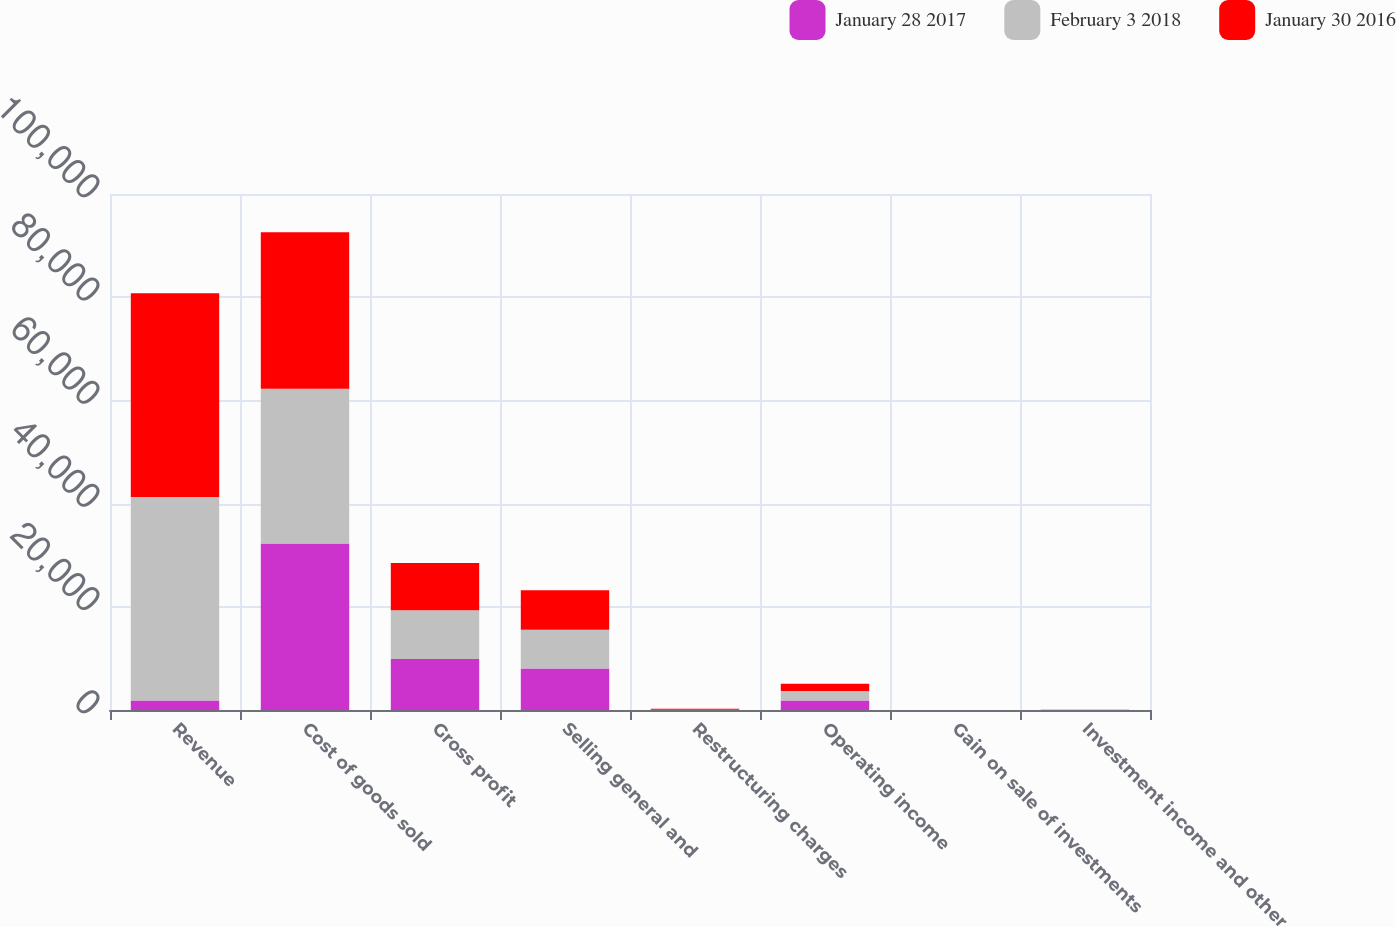Convert chart to OTSL. <chart><loc_0><loc_0><loc_500><loc_500><stacked_bar_chart><ecel><fcel>Revenue<fcel>Cost of goods sold<fcel>Gross profit<fcel>Selling general and<fcel>Restructuring charges<fcel>Operating income<fcel>Gain on sale of investments<fcel>Investment income and other<nl><fcel>January 28 2017<fcel>1854<fcel>32275<fcel>9876<fcel>8023<fcel>10<fcel>1843<fcel>1<fcel>48<nl><fcel>February 3 2018<fcel>39403<fcel>29963<fcel>9440<fcel>7547<fcel>39<fcel>1854<fcel>3<fcel>31<nl><fcel>January 30 2016<fcel>39528<fcel>30334<fcel>9191<fcel>7618<fcel>198<fcel>1375<fcel>2<fcel>13<nl></chart> 